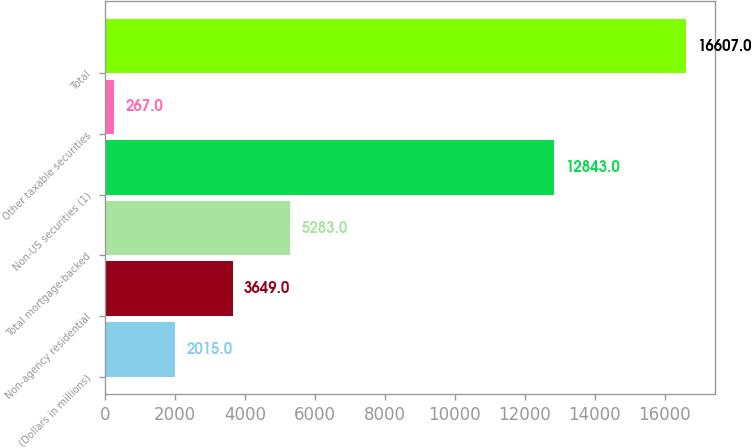Convert chart to OTSL. <chart><loc_0><loc_0><loc_500><loc_500><bar_chart><fcel>(Dollars in millions)<fcel>Non-agency residential<fcel>Total mortgage-backed<fcel>Non-US securities (1)<fcel>Other taxable securities<fcel>Total<nl><fcel>2015<fcel>3649<fcel>5283<fcel>12843<fcel>267<fcel>16607<nl></chart> 